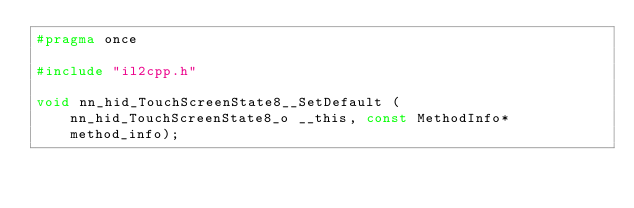<code> <loc_0><loc_0><loc_500><loc_500><_C_>#pragma once

#include "il2cpp.h"

void nn_hid_TouchScreenState8__SetDefault (nn_hid_TouchScreenState8_o __this, const MethodInfo* method_info);
</code> 